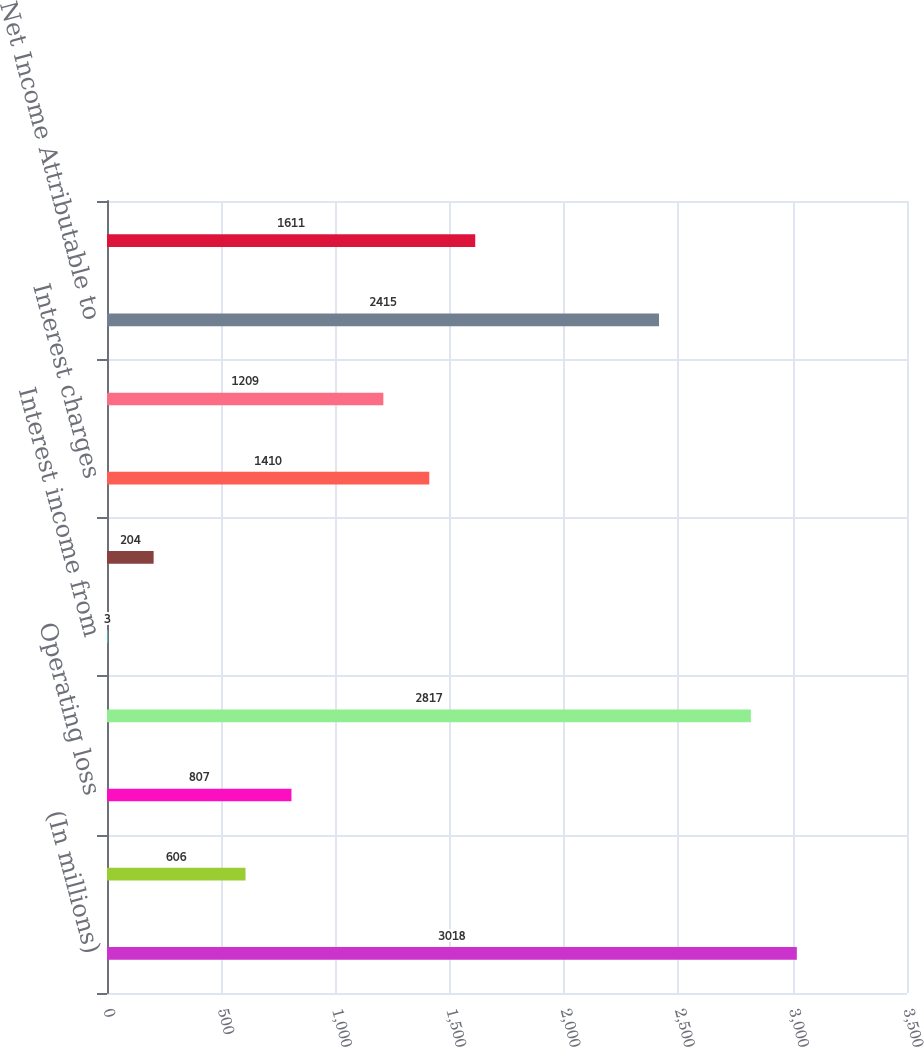<chart> <loc_0><loc_0><loc_500><loc_500><bar_chart><fcel>(In millions)<fcel>Operating expenses<fcel>Operating loss<fcel>Equity in earnings of<fcel>Interest income from<fcel>Miscellaneous expense<fcel>Interest charges<fcel>Income tax (benefit)<fcel>Net Income Attributable to<fcel>Net Income (Loss) Attributable<nl><fcel>3018<fcel>606<fcel>807<fcel>2817<fcel>3<fcel>204<fcel>1410<fcel>1209<fcel>2415<fcel>1611<nl></chart> 